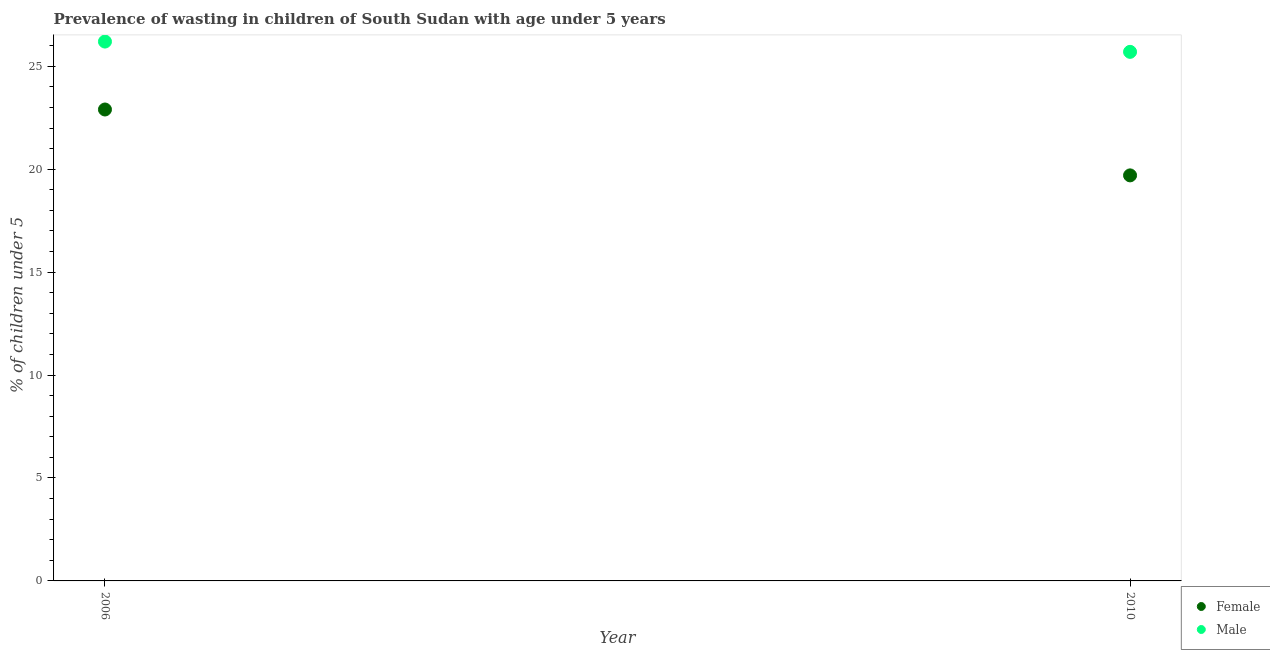Is the number of dotlines equal to the number of legend labels?
Offer a terse response. Yes. What is the percentage of undernourished male children in 2010?
Offer a terse response. 25.7. Across all years, what is the maximum percentage of undernourished male children?
Give a very brief answer. 26.2. Across all years, what is the minimum percentage of undernourished male children?
Provide a succinct answer. 25.7. In which year was the percentage of undernourished male children minimum?
Your answer should be compact. 2010. What is the total percentage of undernourished male children in the graph?
Your answer should be very brief. 51.9. What is the difference between the percentage of undernourished female children in 2006 and that in 2010?
Give a very brief answer. 3.2. What is the difference between the percentage of undernourished male children in 2010 and the percentage of undernourished female children in 2006?
Keep it short and to the point. 2.8. What is the average percentage of undernourished male children per year?
Give a very brief answer. 25.95. What is the ratio of the percentage of undernourished female children in 2006 to that in 2010?
Your response must be concise. 1.16. Is the percentage of undernourished male children in 2006 less than that in 2010?
Offer a terse response. No. Is the percentage of undernourished female children strictly greater than the percentage of undernourished male children over the years?
Give a very brief answer. No. Is the percentage of undernourished male children strictly less than the percentage of undernourished female children over the years?
Provide a succinct answer. No. How many dotlines are there?
Offer a terse response. 2. What is the difference between two consecutive major ticks on the Y-axis?
Your answer should be very brief. 5. Are the values on the major ticks of Y-axis written in scientific E-notation?
Ensure brevity in your answer.  No. Does the graph contain any zero values?
Your answer should be very brief. No. Does the graph contain grids?
Your answer should be compact. No. How many legend labels are there?
Offer a very short reply. 2. What is the title of the graph?
Your answer should be very brief. Prevalence of wasting in children of South Sudan with age under 5 years. What is the label or title of the Y-axis?
Your answer should be compact.  % of children under 5. What is the  % of children under 5 of Female in 2006?
Your answer should be very brief. 22.9. What is the  % of children under 5 of Male in 2006?
Give a very brief answer. 26.2. What is the  % of children under 5 of Female in 2010?
Ensure brevity in your answer.  19.7. What is the  % of children under 5 in Male in 2010?
Provide a succinct answer. 25.7. Across all years, what is the maximum  % of children under 5 of Female?
Offer a very short reply. 22.9. Across all years, what is the maximum  % of children under 5 of Male?
Offer a terse response. 26.2. Across all years, what is the minimum  % of children under 5 of Female?
Your answer should be very brief. 19.7. Across all years, what is the minimum  % of children under 5 in Male?
Provide a short and direct response. 25.7. What is the total  % of children under 5 in Female in the graph?
Your answer should be compact. 42.6. What is the total  % of children under 5 of Male in the graph?
Ensure brevity in your answer.  51.9. What is the difference between the  % of children under 5 in Female in 2006 and that in 2010?
Provide a succinct answer. 3.2. What is the difference between the  % of children under 5 of Female in 2006 and the  % of children under 5 of Male in 2010?
Provide a short and direct response. -2.8. What is the average  % of children under 5 of Female per year?
Your answer should be compact. 21.3. What is the average  % of children under 5 of Male per year?
Provide a short and direct response. 25.95. In the year 2006, what is the difference between the  % of children under 5 of Female and  % of children under 5 of Male?
Ensure brevity in your answer.  -3.3. In the year 2010, what is the difference between the  % of children under 5 in Female and  % of children under 5 in Male?
Provide a succinct answer. -6. What is the ratio of the  % of children under 5 in Female in 2006 to that in 2010?
Provide a succinct answer. 1.16. What is the ratio of the  % of children under 5 in Male in 2006 to that in 2010?
Offer a terse response. 1.02. What is the difference between the highest and the lowest  % of children under 5 in Female?
Provide a short and direct response. 3.2. What is the difference between the highest and the lowest  % of children under 5 in Male?
Your answer should be compact. 0.5. 